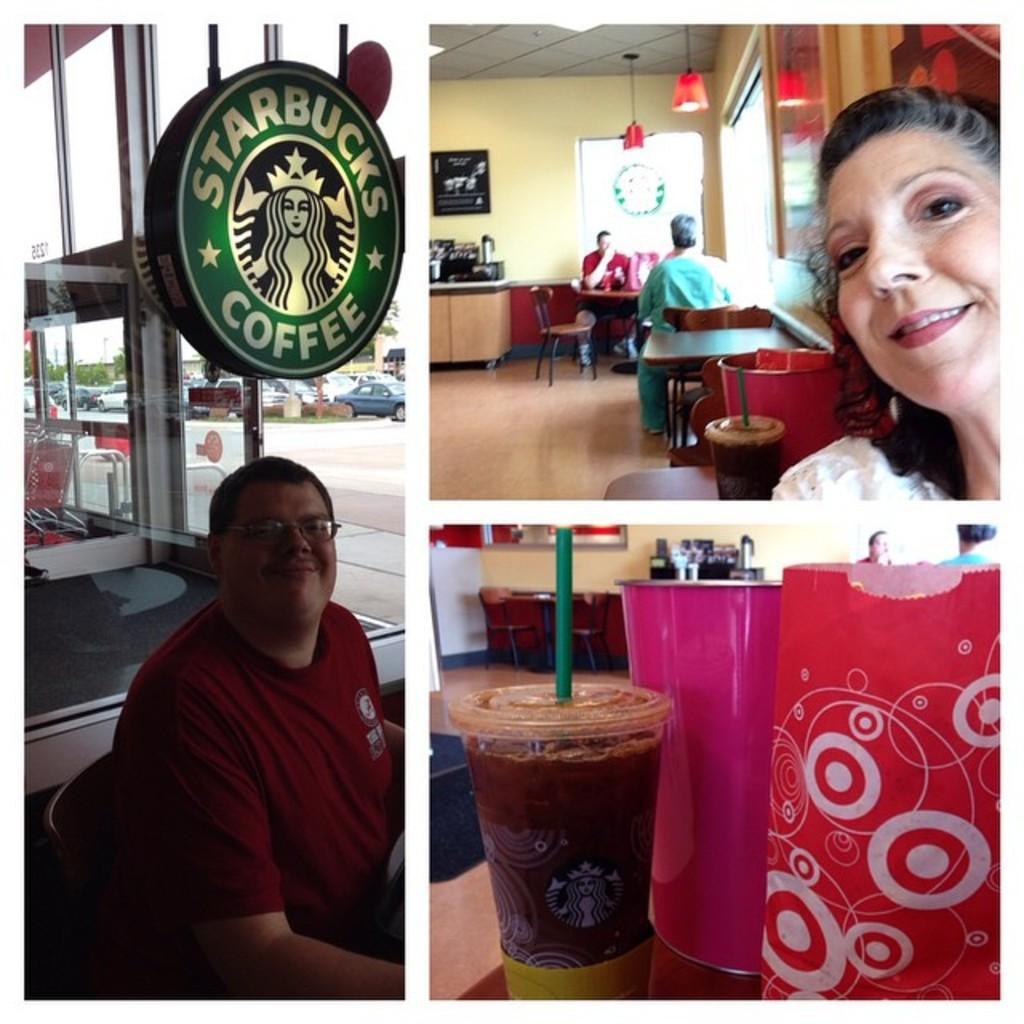In one or two sentences, can you explain what this image depicts? In this picture there is collages of three images. On the left side of the image there is a person sitting and smiling and on the top of the person there is a board with some text written on it and there are windows and there is a door and behind the windows there are cars and there are trees. On the right side of the image on the top right there are persons sitting and there is a woman in the front smiling. In the center there is table and there is a bin which is red in colour and there is a wooden table and on the table there are black colour objects and there are lights hanging, and on the wall there is a frame, on the top right of the image on the right side there is window. On the bottom right of the image in the front there is a glass and there are objects which are white and pink in colour. In the background there is a wooden table and on the right side of the table there are objects which are black in colour and there are persons visible. 